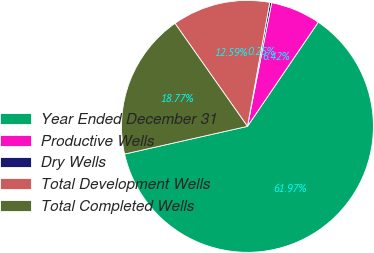Convert chart to OTSL. <chart><loc_0><loc_0><loc_500><loc_500><pie_chart><fcel>Year Ended December 31<fcel>Productive Wells<fcel>Dry Wells<fcel>Total Development Wells<fcel>Total Completed Wells<nl><fcel>61.98%<fcel>6.42%<fcel>0.25%<fcel>12.59%<fcel>18.77%<nl></chart> 